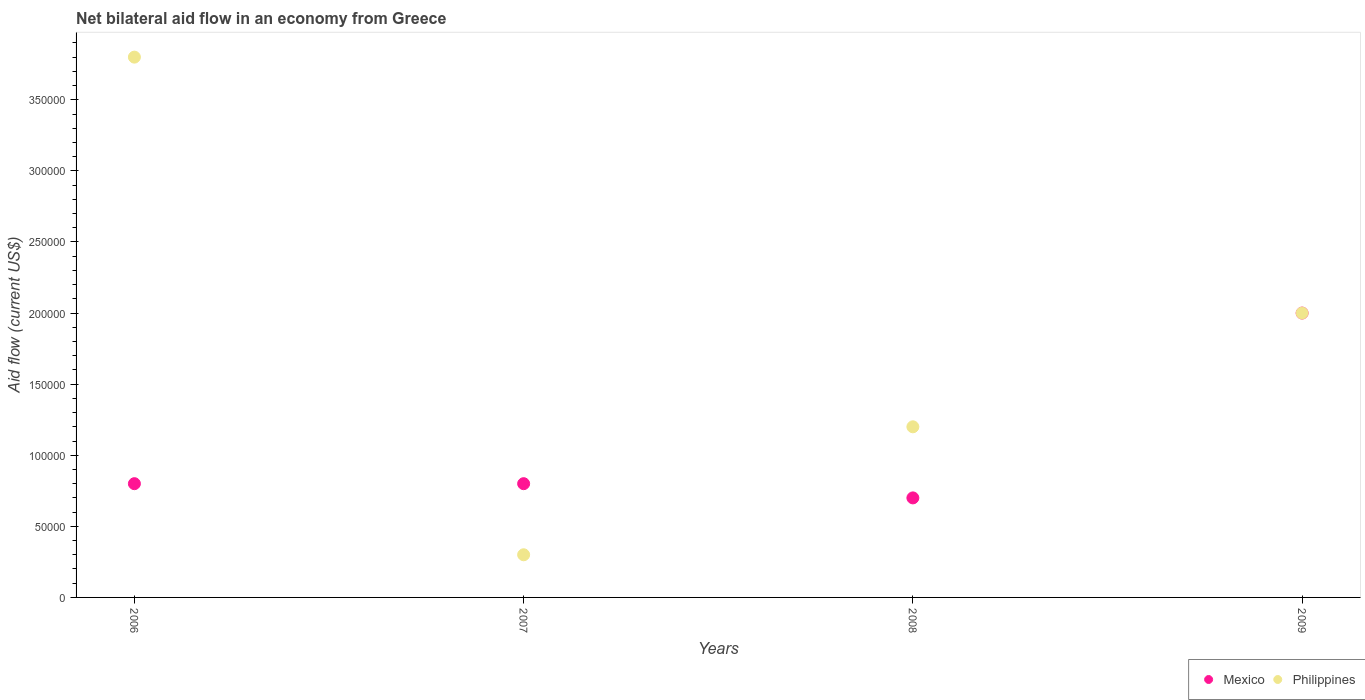How many different coloured dotlines are there?
Your response must be concise. 2. Is the number of dotlines equal to the number of legend labels?
Offer a terse response. Yes. Across all years, what is the minimum net bilateral aid flow in Mexico?
Keep it short and to the point. 7.00e+04. In which year was the net bilateral aid flow in Philippines maximum?
Give a very brief answer. 2006. In which year was the net bilateral aid flow in Mexico minimum?
Provide a short and direct response. 2008. What is the total net bilateral aid flow in Philippines in the graph?
Keep it short and to the point. 7.30e+05. What is the difference between the net bilateral aid flow in Mexico in 2007 and that in 2009?
Provide a short and direct response. -1.20e+05. What is the difference between the net bilateral aid flow in Mexico in 2006 and the net bilateral aid flow in Philippines in 2009?
Offer a very short reply. -1.20e+05. What is the average net bilateral aid flow in Philippines per year?
Offer a terse response. 1.82e+05. In how many years, is the net bilateral aid flow in Philippines greater than 60000 US$?
Provide a short and direct response. 3. What is the ratio of the net bilateral aid flow in Philippines in 2008 to that in 2009?
Your answer should be very brief. 0.6. Is the net bilateral aid flow in Philippines in 2007 less than that in 2008?
Provide a short and direct response. Yes. What is the difference between the highest and the second highest net bilateral aid flow in Philippines?
Your answer should be compact. 1.80e+05. What is the difference between the highest and the lowest net bilateral aid flow in Philippines?
Your response must be concise. 3.50e+05. Is the sum of the net bilateral aid flow in Philippines in 2006 and 2009 greater than the maximum net bilateral aid flow in Mexico across all years?
Offer a terse response. Yes. Does the net bilateral aid flow in Mexico monotonically increase over the years?
Your response must be concise. No. Is the net bilateral aid flow in Mexico strictly greater than the net bilateral aid flow in Philippines over the years?
Provide a succinct answer. No. What is the difference between two consecutive major ticks on the Y-axis?
Keep it short and to the point. 5.00e+04. Are the values on the major ticks of Y-axis written in scientific E-notation?
Provide a short and direct response. No. Does the graph contain any zero values?
Keep it short and to the point. No. Does the graph contain grids?
Offer a very short reply. No. How many legend labels are there?
Ensure brevity in your answer.  2. What is the title of the graph?
Offer a terse response. Net bilateral aid flow in an economy from Greece. What is the Aid flow (current US$) of Philippines in 2007?
Provide a succinct answer. 3.00e+04. What is the Aid flow (current US$) in Philippines in 2008?
Provide a short and direct response. 1.20e+05. What is the Aid flow (current US$) in Mexico in 2009?
Provide a short and direct response. 2.00e+05. Across all years, what is the maximum Aid flow (current US$) in Mexico?
Provide a succinct answer. 2.00e+05. Across all years, what is the maximum Aid flow (current US$) in Philippines?
Offer a terse response. 3.80e+05. Across all years, what is the minimum Aid flow (current US$) of Mexico?
Provide a succinct answer. 7.00e+04. Across all years, what is the minimum Aid flow (current US$) of Philippines?
Give a very brief answer. 3.00e+04. What is the total Aid flow (current US$) of Philippines in the graph?
Provide a short and direct response. 7.30e+05. What is the difference between the Aid flow (current US$) in Mexico in 2006 and that in 2007?
Your response must be concise. 0. What is the difference between the Aid flow (current US$) in Philippines in 2006 and that in 2007?
Keep it short and to the point. 3.50e+05. What is the difference between the Aid flow (current US$) in Mexico in 2006 and that in 2008?
Your answer should be compact. 10000. What is the difference between the Aid flow (current US$) of Philippines in 2006 and that in 2008?
Give a very brief answer. 2.60e+05. What is the difference between the Aid flow (current US$) of Mexico in 2007 and that in 2008?
Ensure brevity in your answer.  10000. What is the difference between the Aid flow (current US$) in Philippines in 2007 and that in 2008?
Your answer should be compact. -9.00e+04. What is the difference between the Aid flow (current US$) of Philippines in 2007 and that in 2009?
Offer a very short reply. -1.70e+05. What is the difference between the Aid flow (current US$) of Philippines in 2008 and that in 2009?
Provide a short and direct response. -8.00e+04. What is the difference between the Aid flow (current US$) of Mexico in 2006 and the Aid flow (current US$) of Philippines in 2007?
Offer a terse response. 5.00e+04. What is the difference between the Aid flow (current US$) of Mexico in 2006 and the Aid flow (current US$) of Philippines in 2008?
Keep it short and to the point. -4.00e+04. What is the difference between the Aid flow (current US$) of Mexico in 2006 and the Aid flow (current US$) of Philippines in 2009?
Keep it short and to the point. -1.20e+05. What is the difference between the Aid flow (current US$) of Mexico in 2007 and the Aid flow (current US$) of Philippines in 2008?
Provide a short and direct response. -4.00e+04. What is the difference between the Aid flow (current US$) in Mexico in 2008 and the Aid flow (current US$) in Philippines in 2009?
Provide a succinct answer. -1.30e+05. What is the average Aid flow (current US$) of Mexico per year?
Offer a terse response. 1.08e+05. What is the average Aid flow (current US$) of Philippines per year?
Provide a succinct answer. 1.82e+05. In the year 2006, what is the difference between the Aid flow (current US$) in Mexico and Aid flow (current US$) in Philippines?
Provide a short and direct response. -3.00e+05. In the year 2007, what is the difference between the Aid flow (current US$) in Mexico and Aid flow (current US$) in Philippines?
Your answer should be compact. 5.00e+04. In the year 2009, what is the difference between the Aid flow (current US$) in Mexico and Aid flow (current US$) in Philippines?
Keep it short and to the point. 0. What is the ratio of the Aid flow (current US$) of Philippines in 2006 to that in 2007?
Your answer should be very brief. 12.67. What is the ratio of the Aid flow (current US$) of Philippines in 2006 to that in 2008?
Your answer should be compact. 3.17. What is the ratio of the Aid flow (current US$) in Philippines in 2006 to that in 2009?
Your answer should be very brief. 1.9. What is the ratio of the Aid flow (current US$) in Mexico in 2007 to that in 2008?
Ensure brevity in your answer.  1.14. What is the ratio of the Aid flow (current US$) in Philippines in 2007 to that in 2009?
Make the answer very short. 0.15. What is the ratio of the Aid flow (current US$) of Mexico in 2008 to that in 2009?
Your response must be concise. 0.35. What is the difference between the highest and the second highest Aid flow (current US$) in Philippines?
Give a very brief answer. 1.80e+05. 